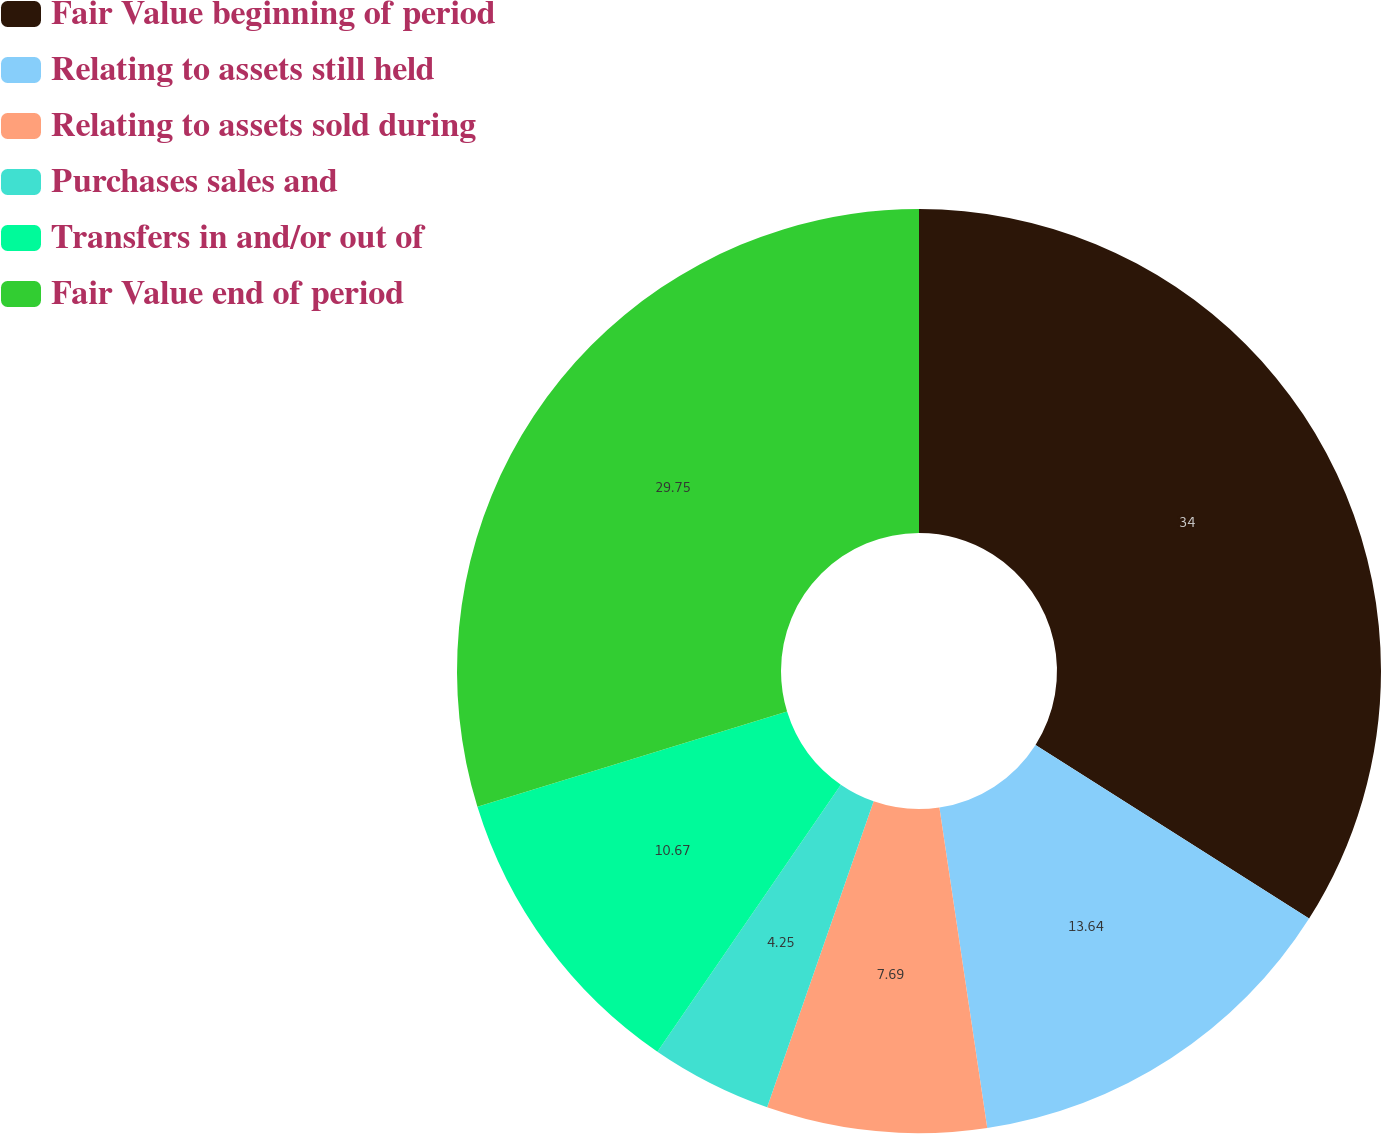Convert chart to OTSL. <chart><loc_0><loc_0><loc_500><loc_500><pie_chart><fcel>Fair Value beginning of period<fcel>Relating to assets still held<fcel>Relating to assets sold during<fcel>Purchases sales and<fcel>Transfers in and/or out of<fcel>Fair Value end of period<nl><fcel>34.0%<fcel>13.64%<fcel>7.69%<fcel>4.25%<fcel>10.67%<fcel>29.75%<nl></chart> 